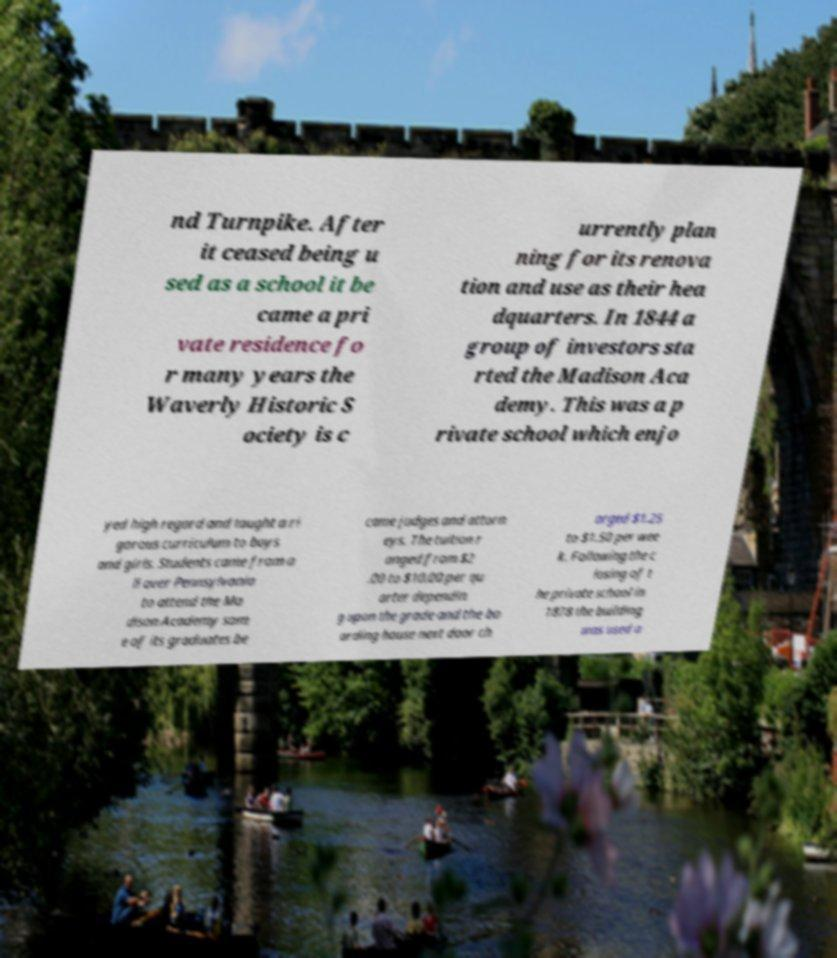Please read and relay the text visible in this image. What does it say? nd Turnpike. After it ceased being u sed as a school it be came a pri vate residence fo r many years the Waverly Historic S ociety is c urrently plan ning for its renova tion and use as their hea dquarters. In 1844 a group of investors sta rted the Madison Aca demy. This was a p rivate school which enjo yed high regard and taught a ri gorous curriculum to boys and girls. Students came from a ll over Pennsylvania to attend the Ma dison Academy som e of its graduates be came judges and attorn eys. The tuition r anged from $2 .00 to $10.00 per qu arter dependin g upon the grade and the bo arding house next door ch arged $1.25 to $1.50 per wee k. Following the c losing of t he private school in 1878 the building was used a 